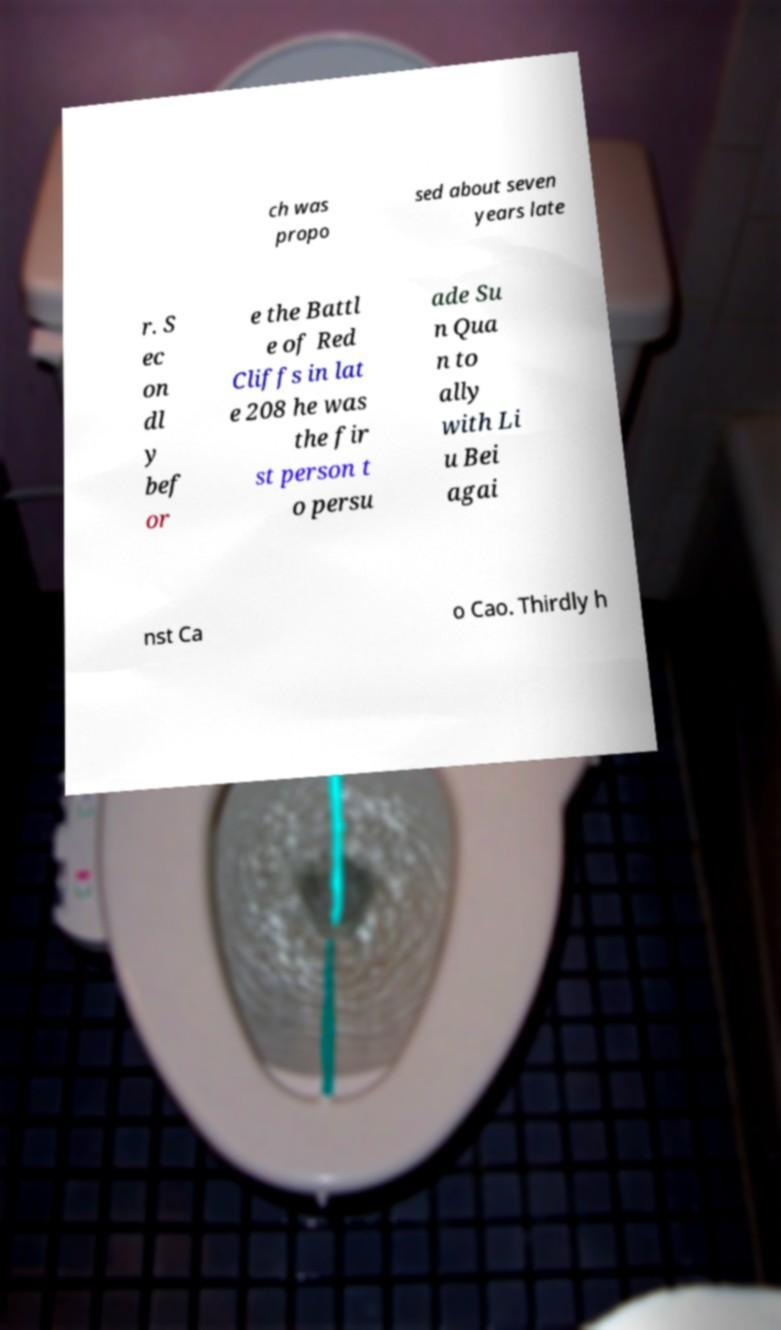Please read and relay the text visible in this image. What does it say? ch was propo sed about seven years late r. S ec on dl y bef or e the Battl e of Red Cliffs in lat e 208 he was the fir st person t o persu ade Su n Qua n to ally with Li u Bei agai nst Ca o Cao. Thirdly h 